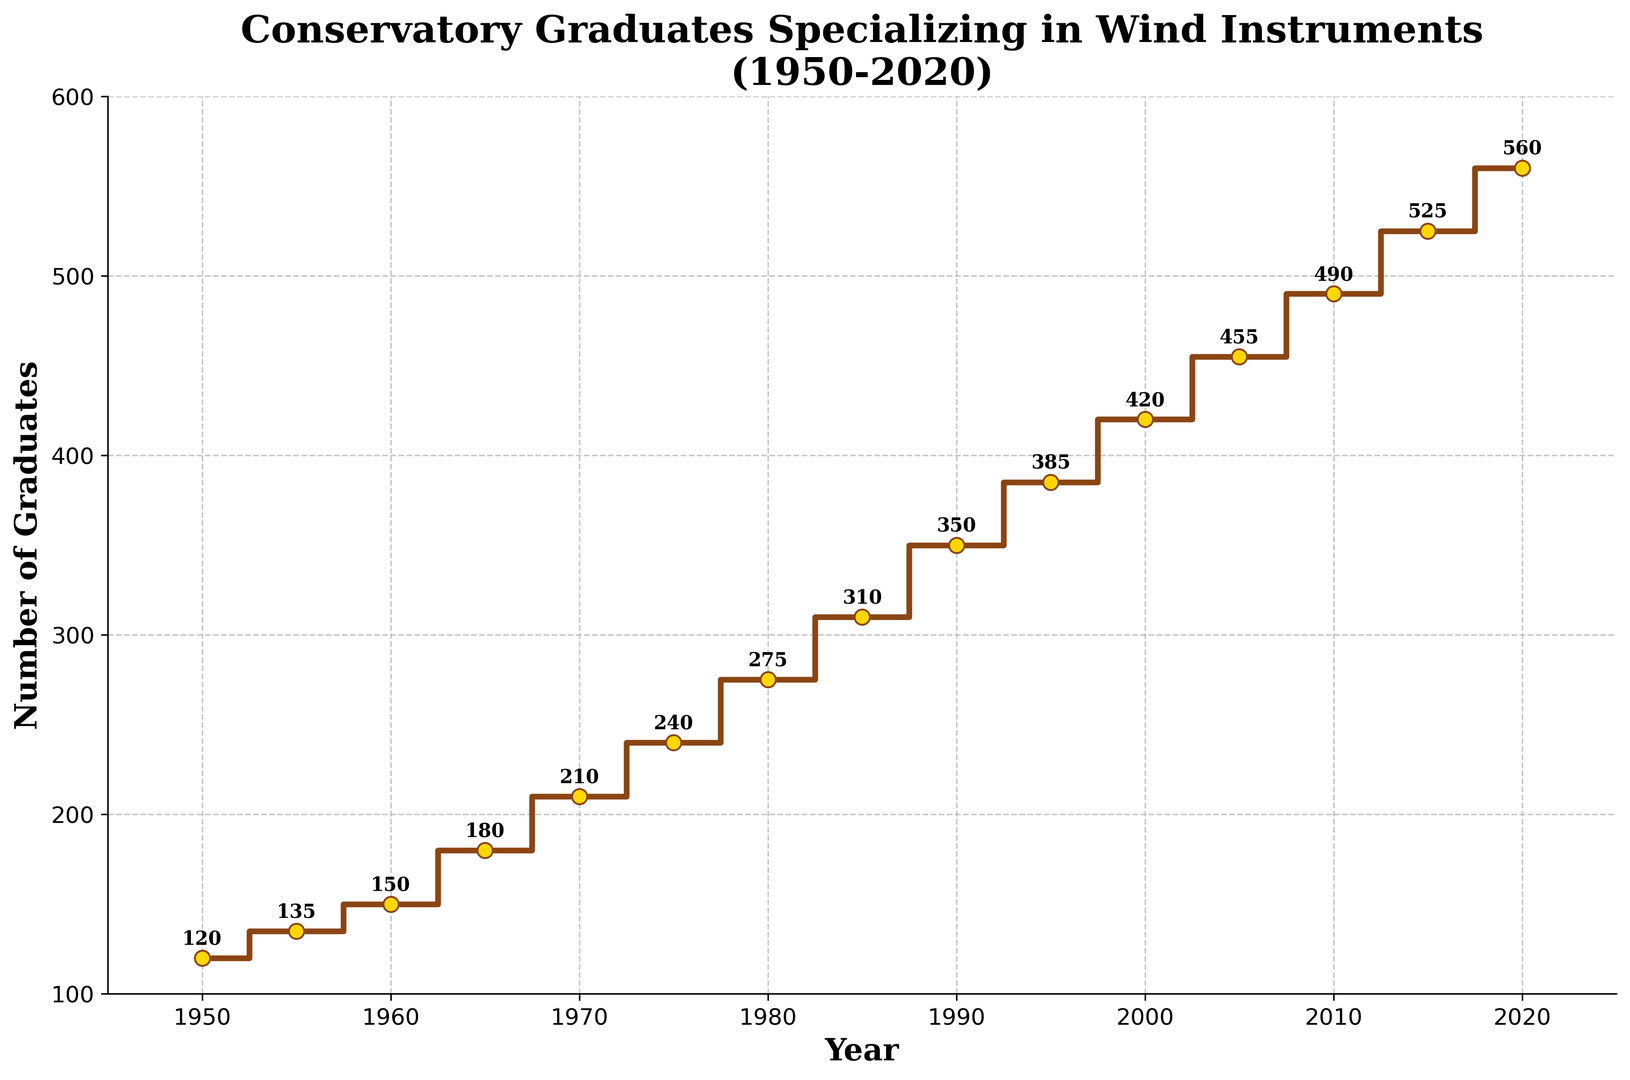what year did the number of graduates reach 210? From the plot, trace the year corresponding to the number 210 on the y-axis. The year is shown at 1970.
Answer: 1970 How much did the number of graduates increase from 1950 to 1965? The number of graduates in 1950 is 120, and in 1965 it is 180. The increase is 180 - 120 = 60.
Answer: 60 Which year had the highest number of graduates? The highest point on the stair plot is in 2020, reaching 560 graduates.
Answer: 2020 How many graduates were there in 1985 compared to 1990? In 1985, the number is 310; in 1990, it is 350. The difference is 350 - 310 = 40.
Answer: 40 What is the average number of graduates between 2000 and 2020? Sum the graduates for years 2000, 2005, 2010, 2015, 2020 and divide by the number of years: (420 + 455 + 490 + 525 + 560) / 5 = 490.
Answer: 490 What is the color of the markers used in the plot? The markers used in the plot are gold in color. This can be seen from the description of the markers in the code.
Answer: gold Compare the growth in graduates from 1950 to 1980 and from 1980 to 2010. From 1950 to 1980, the increase is 275 - 120 = 155. From 1980 to 2010, it is 490 - 275 = 215. Thus, the second period saw a larger increase.
Answer: 215 At what intervals do the markers show significant data points on the plot? The markers are drawn at each 5-year interval, starting from 1950 up to 2020.
Answer: every 5 years What is the total number of graduates from 1950 to 2020? Sum all given graduate numbers: 120 + 135 + 150 + 180 + 210 + 240 + 275 + 310 + 350 + 385 + 420 + 455 + 490 + 525 + 560 = 4705.
Answer: 4705 